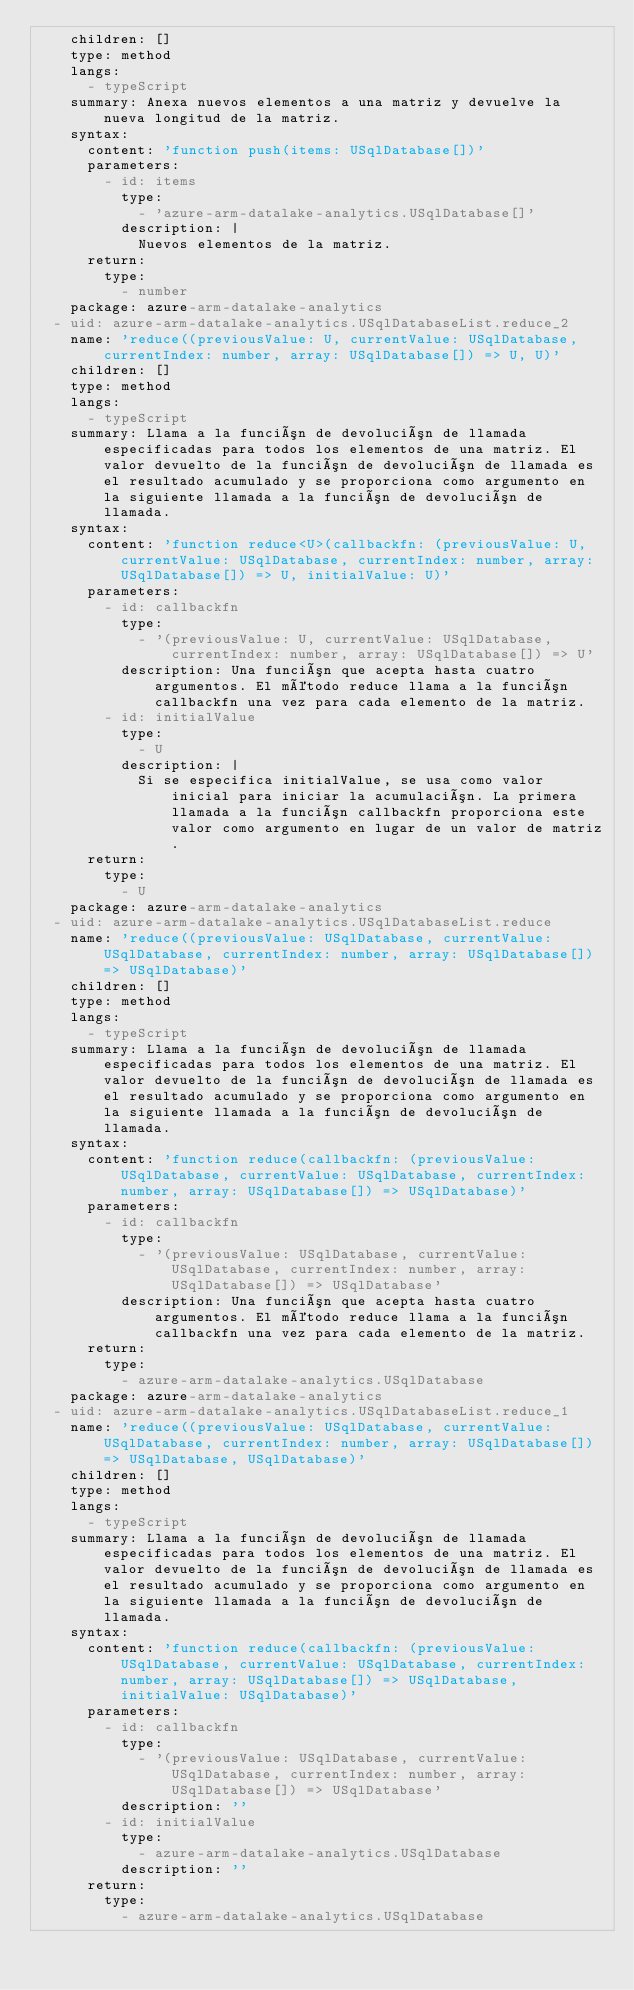<code> <loc_0><loc_0><loc_500><loc_500><_YAML_>    children: []
    type: method
    langs:
      - typeScript
    summary: Anexa nuevos elementos a una matriz y devuelve la nueva longitud de la matriz.
    syntax:
      content: 'function push(items: USqlDatabase[])'
      parameters:
        - id: items
          type:
            - 'azure-arm-datalake-analytics.USqlDatabase[]'
          description: |
            Nuevos elementos de la matriz.
      return:
        type:
          - number
    package: azure-arm-datalake-analytics
  - uid: azure-arm-datalake-analytics.USqlDatabaseList.reduce_2
    name: 'reduce((previousValue: U, currentValue: USqlDatabase, currentIndex: number, array: USqlDatabase[]) => U, U)'
    children: []
    type: method
    langs:
      - typeScript
    summary: Llama a la función de devolución de llamada especificadas para todos los elementos de una matriz. El valor devuelto de la función de devolución de llamada es el resultado acumulado y se proporciona como argumento en la siguiente llamada a la función de devolución de llamada.
    syntax:
      content: 'function reduce<U>(callbackfn: (previousValue: U, currentValue: USqlDatabase, currentIndex: number, array: USqlDatabase[]) => U, initialValue: U)'
      parameters:
        - id: callbackfn
          type:
            - '(previousValue: U, currentValue: USqlDatabase, currentIndex: number, array: USqlDatabase[]) => U'
          description: Una función que acepta hasta cuatro argumentos. El método reduce llama a la función callbackfn una vez para cada elemento de la matriz.
        - id: initialValue
          type:
            - U
          description: |
            Si se especifica initialValue, se usa como valor inicial para iniciar la acumulación. La primera llamada a la función callbackfn proporciona este valor como argumento en lugar de un valor de matriz.
      return:
        type:
          - U
    package: azure-arm-datalake-analytics
  - uid: azure-arm-datalake-analytics.USqlDatabaseList.reduce
    name: 'reduce((previousValue: USqlDatabase, currentValue: USqlDatabase, currentIndex: number, array: USqlDatabase[]) => USqlDatabase)'
    children: []
    type: method
    langs:
      - typeScript
    summary: Llama a la función de devolución de llamada especificadas para todos los elementos de una matriz. El valor devuelto de la función de devolución de llamada es el resultado acumulado y se proporciona como argumento en la siguiente llamada a la función de devolución de llamada.
    syntax:
      content: 'function reduce(callbackfn: (previousValue: USqlDatabase, currentValue: USqlDatabase, currentIndex: number, array: USqlDatabase[]) => USqlDatabase)'
      parameters:
        - id: callbackfn
          type:
            - '(previousValue: USqlDatabase, currentValue: USqlDatabase, currentIndex: number, array: USqlDatabase[]) => USqlDatabase'
          description: Una función que acepta hasta cuatro argumentos. El método reduce llama a la función callbackfn una vez para cada elemento de la matriz.
      return:
        type:
          - azure-arm-datalake-analytics.USqlDatabase
    package: azure-arm-datalake-analytics
  - uid: azure-arm-datalake-analytics.USqlDatabaseList.reduce_1
    name: 'reduce((previousValue: USqlDatabase, currentValue: USqlDatabase, currentIndex: number, array: USqlDatabase[]) => USqlDatabase, USqlDatabase)'
    children: []
    type: method
    langs:
      - typeScript
    summary: Llama a la función de devolución de llamada especificadas para todos los elementos de una matriz. El valor devuelto de la función de devolución de llamada es el resultado acumulado y se proporciona como argumento en la siguiente llamada a la función de devolución de llamada.
    syntax:
      content: 'function reduce(callbackfn: (previousValue: USqlDatabase, currentValue: USqlDatabase, currentIndex: number, array: USqlDatabase[]) => USqlDatabase, initialValue: USqlDatabase)'
      parameters:
        - id: callbackfn
          type:
            - '(previousValue: USqlDatabase, currentValue: USqlDatabase, currentIndex: number, array: USqlDatabase[]) => USqlDatabase'
          description: ''
        - id: initialValue
          type:
            - azure-arm-datalake-analytics.USqlDatabase
          description: ''
      return:
        type:
          - azure-arm-datalake-analytics.USqlDatabase</code> 